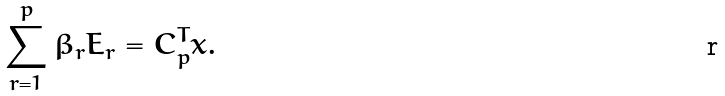<formula> <loc_0><loc_0><loc_500><loc_500>\sum _ { r = 1 } ^ { p } \beta _ { r } E _ { r } = C _ { p } ^ { T } x .</formula> 